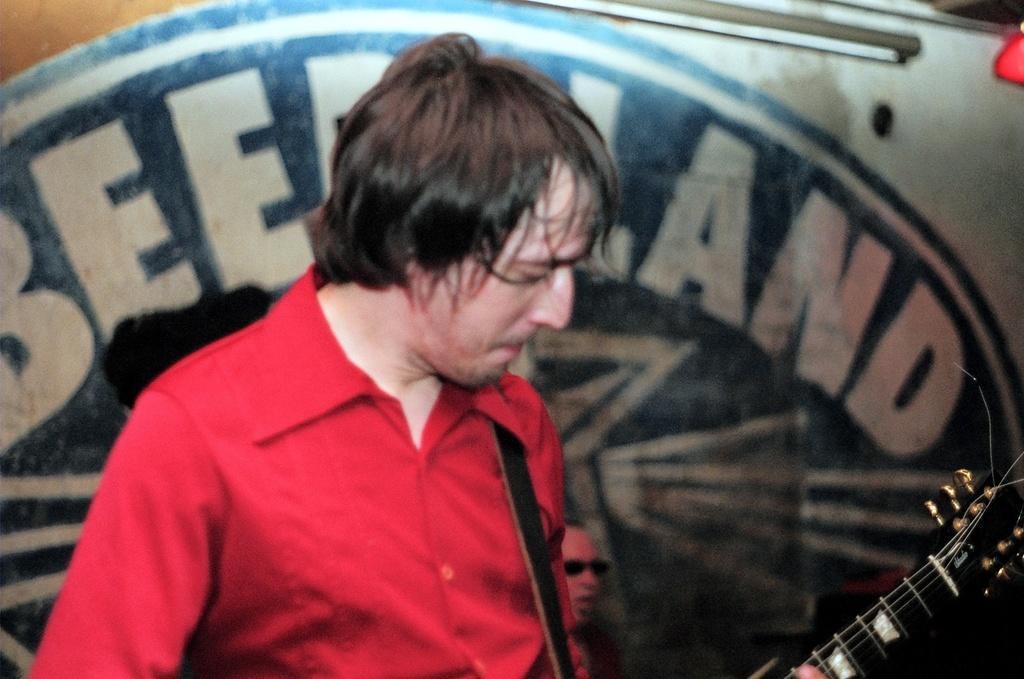Can you describe this image briefly? In the image we can see a man wearing red color shirt and holding a guitar in his hand. 